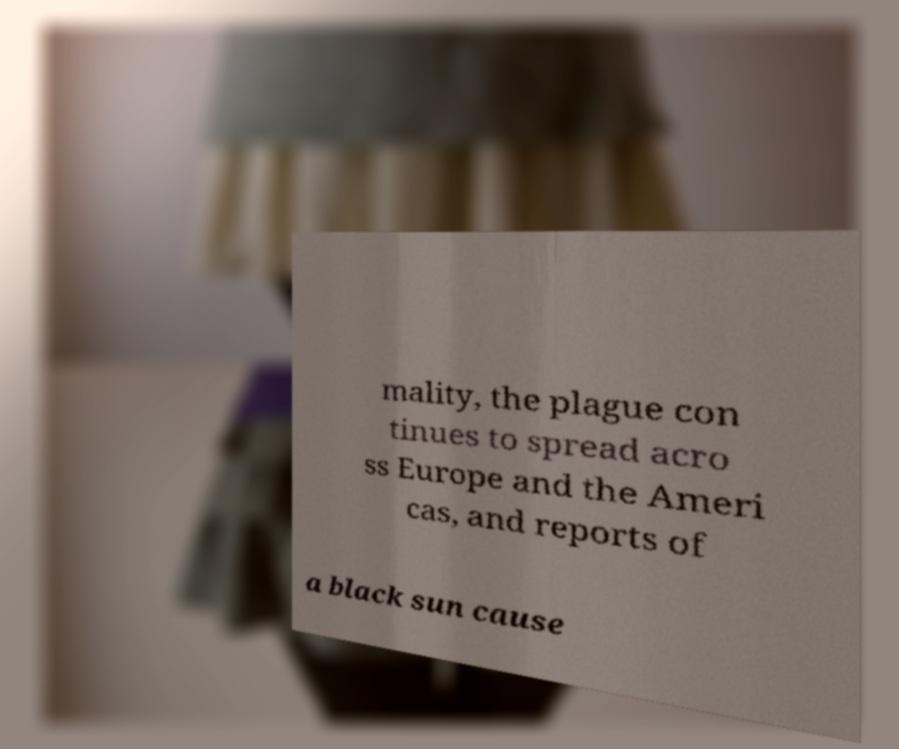What messages or text are displayed in this image? I need them in a readable, typed format. mality, the plague con tinues to spread acro ss Europe and the Ameri cas, and reports of a black sun cause 